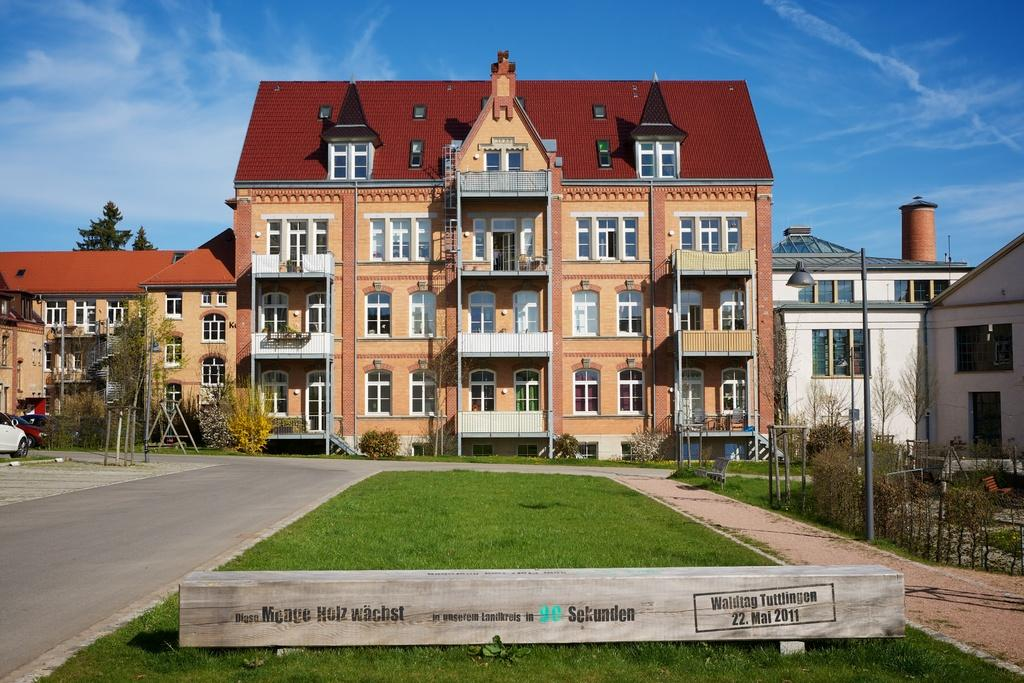What is located in the middle of the picture? There are buildings in the middle of the picture. What is on the ground in front of the buildings? There is grass on the ground in front of the buildings. What can be seen in the background of the image? The sky is visible in the background of the image. Where is the chair located in the image? There is no chair present in the image. What type of office can be seen in the background of the image? There is no office visible in the image; only buildings, grass, and the sky are present. 